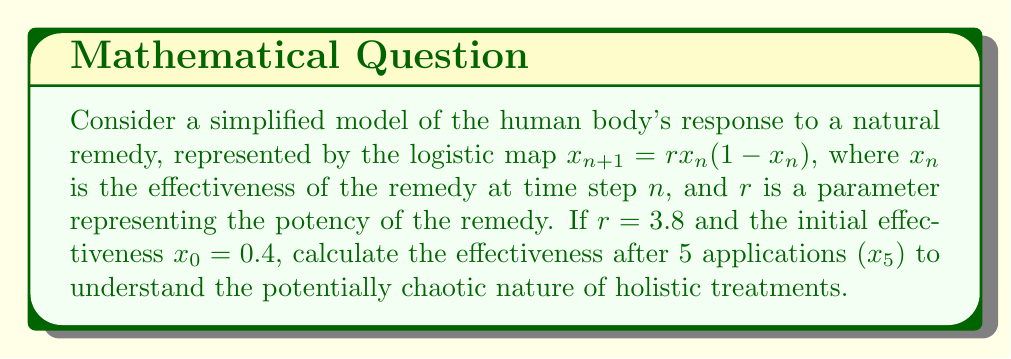Solve this math problem. To solve this problem, we'll iterate the logistic map equation five times:

1) For $n = 0$:
   $x_1 = r \cdot x_0 \cdot (1-x_0) = 3.8 \cdot 0.4 \cdot (1-0.4) = 0.912$

2) For $n = 1$:
   $x_2 = r \cdot x_1 \cdot (1-x_1) = 3.8 \cdot 0.912 \cdot (1-0.912) = 0.305472$

3) For $n = 2$:
   $x_3 = r \cdot x_2 \cdot (1-x_2) = 3.8 \cdot 0.305472 \cdot (1-0.305472) = 0.805878$

4) For $n = 3$:
   $x_4 = r \cdot x_3 \cdot (1-x_3) = 3.8 \cdot 0.805878 \cdot (1-0.805878) = 0.595308$

5) For $n = 4$:
   $x_5 = r \cdot x_4 \cdot (1-x_4) = 3.8 \cdot 0.595308 \cdot (1-0.595308) = 0.915391$

The effectiveness after 5 applications is approximately 0.915391.

This demonstrates the potentially chaotic nature of holistic treatments, as small changes in initial conditions or parameters can lead to significantly different outcomes over time.
Answer: 0.915391 